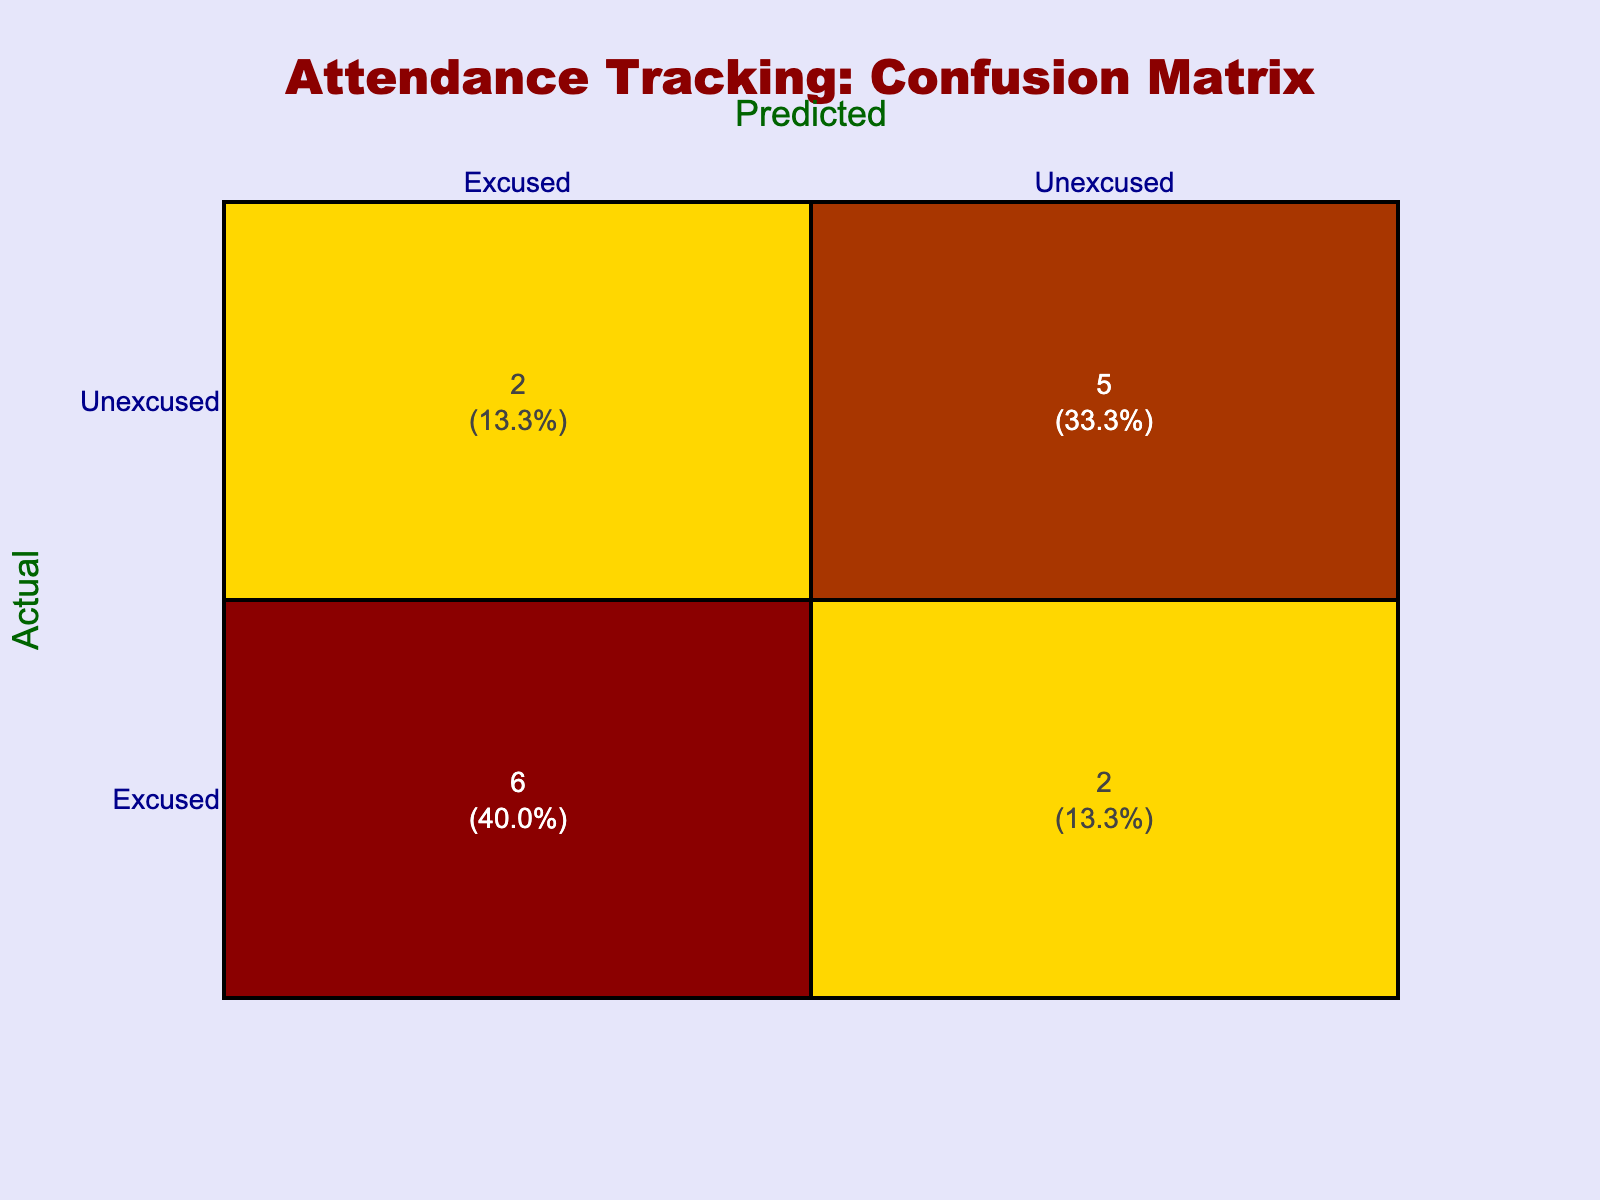What is the total number of Excused absences predicted? To find the total predicted Excused absences, look at the "Predicted" column for "Excused." There are three occurrences: StudentID 1001, 1004, and 1007. Thus, the total is 3.
Answer: 3 How many students were incorrectly classified as Unexcused when they were actually Excused? The count of students with Actual Status of Excused and Predicted Status of Unexcused can be checked in the table. There is one occurrence: StudentID 1011. So, the total is 1.
Answer: 1 What percentage of actual Unexcused absences were predicted correctly? First, determine the actual Unexcused count, which is 6 (Students 1003, 1005, 1006, 1008, 1012, and 1014). Then, find the predicted Unexcused count that matches this, which is 5 (Students 1003, 1006, 1010, 1012, and 1014). To get the percentage: (5/6) * 100 = 83.3%.
Answer: 83.3% How many total absences were classified correctly? The correct classifications consist of both Excused-Excused and Unexcused-Unexcused predictions. From the matrix, there are 3 Excused-Excused (1001, 1004, and 1007) and 5 Unexcused-Unexcused (1003, 1006, 1010, 1012, and 1014). Adding these gives 3 + 5 = 8 correct classifications.
Answer: 8 Is it true that more students were incorrectly predicted as Excused than Unexcused? To verify this, we need to check the incorrect predictions. There were 3 incorrectly predicted as Excused (1011, 1005, 1008) against 1 predicted as Unexcused (1002). Since 3 is greater than 1, the statement is true.
Answer: Yes What is the average number of Excused absences predicted across all students? To calculate the average, we first count the total predicted Excused absences, which is 3, and divide by the total number of students, which is 15. Thus, the average is 3/15 = 0.2.
Answer: 0.2 How many students had no absences predicted correctly? Check for students who are both incorrectly predicted as Excused and those predicted as Unexcused without any correctly scheduled absence. It seems the students are students 1002 and 1005, thus totaling 2 students.
Answer: 2 Determine the difference between Excused absences and Unexcused absences correctly predicted. The count of correctly predicted Excused absences is 3, while Unexcused absences correctly predicted is also 5. The difference is calculated as 3 - 5 = -2, meaning 2 more Unexcused were predicted correctly than Excused.
Answer: -2 